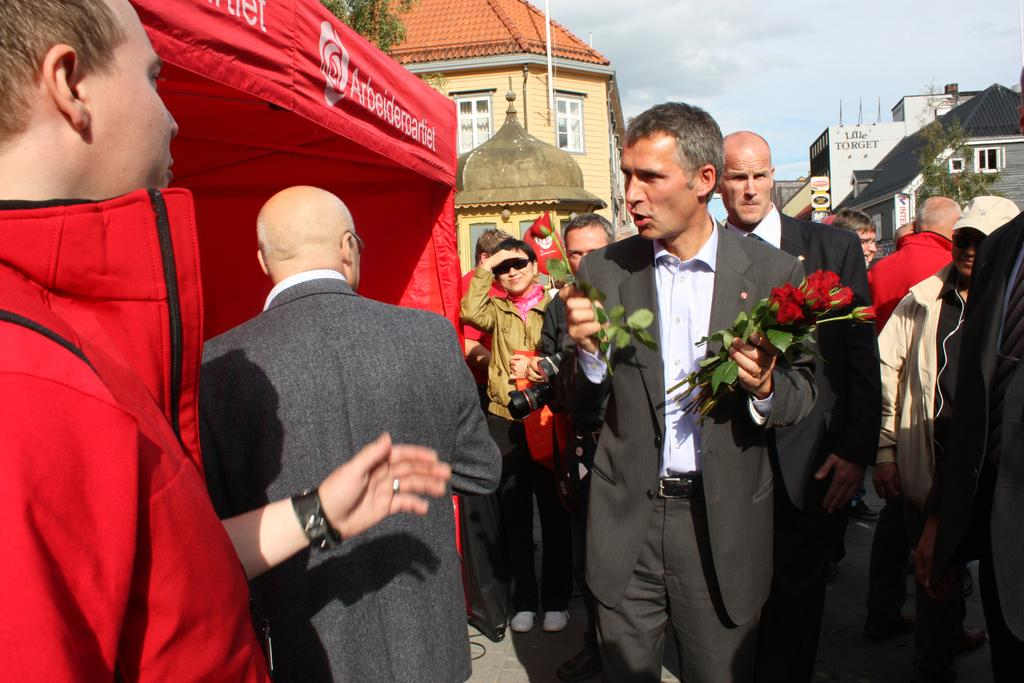What is happening on the road in the image? There are people on the road in the image. Can you describe one of the people in the image? One person is holding flowers in their hands. What structure can be seen in the image? There is a tent in the image. What can be seen in the background of the image? There are buildings, trees, boards, and the sky visible in the background of the image. What type of produce is being harvested with a rake in the image? There is no produce or rake present in the image. What color is the linen draped over the tent in the image? There is no linen present in the image; only a tent is visible. 